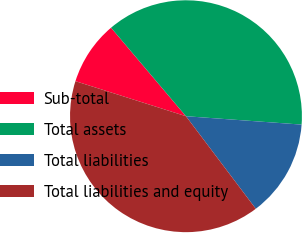Convert chart to OTSL. <chart><loc_0><loc_0><loc_500><loc_500><pie_chart><fcel>Sub-total<fcel>Total assets<fcel>Total liabilities<fcel>Total liabilities and equity<nl><fcel>8.93%<fcel>37.33%<fcel>13.56%<fcel>40.17%<nl></chart> 